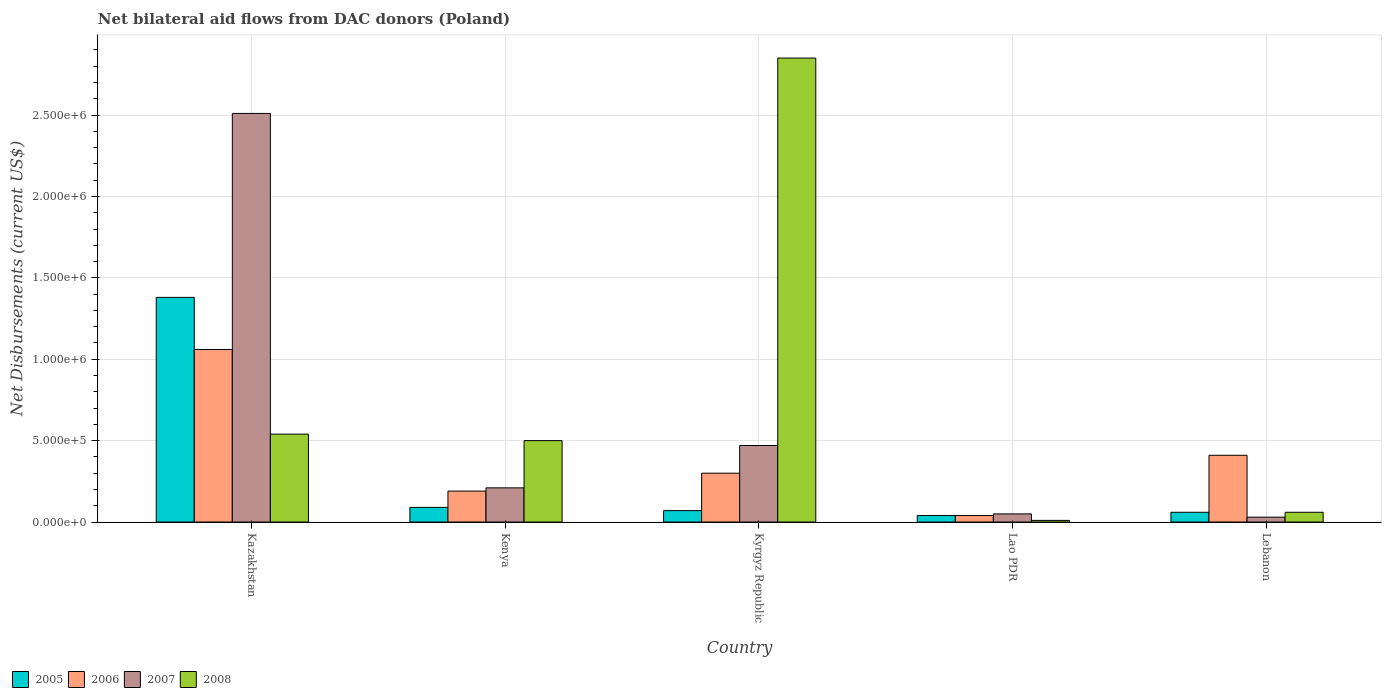How many different coloured bars are there?
Give a very brief answer. 4. How many groups of bars are there?
Ensure brevity in your answer.  5. Are the number of bars per tick equal to the number of legend labels?
Provide a short and direct response. Yes. Are the number of bars on each tick of the X-axis equal?
Keep it short and to the point. Yes. How many bars are there on the 1st tick from the left?
Offer a very short reply. 4. How many bars are there on the 4th tick from the right?
Your answer should be compact. 4. What is the label of the 5th group of bars from the left?
Give a very brief answer. Lebanon. In how many cases, is the number of bars for a given country not equal to the number of legend labels?
Your answer should be very brief. 0. What is the net bilateral aid flows in 2006 in Lebanon?
Keep it short and to the point. 4.10e+05. Across all countries, what is the maximum net bilateral aid flows in 2005?
Offer a very short reply. 1.38e+06. In which country was the net bilateral aid flows in 2006 maximum?
Give a very brief answer. Kazakhstan. In which country was the net bilateral aid flows in 2007 minimum?
Ensure brevity in your answer.  Lebanon. What is the total net bilateral aid flows in 2005 in the graph?
Ensure brevity in your answer.  1.64e+06. What is the difference between the net bilateral aid flows in 2008 in Kazakhstan and that in Lao PDR?
Offer a terse response. 5.30e+05. What is the difference between the net bilateral aid flows in 2008 in Kenya and the net bilateral aid flows in 2005 in Lao PDR?
Keep it short and to the point. 4.60e+05. What is the average net bilateral aid flows in 2005 per country?
Offer a terse response. 3.28e+05. Is the net bilateral aid flows in 2005 in Kazakhstan less than that in Lao PDR?
Keep it short and to the point. No. What is the difference between the highest and the second highest net bilateral aid flows in 2007?
Your answer should be very brief. 2.04e+06. What is the difference between the highest and the lowest net bilateral aid flows in 2007?
Ensure brevity in your answer.  2.48e+06. What does the 3rd bar from the left in Kenya represents?
Offer a very short reply. 2007. How many bars are there?
Ensure brevity in your answer.  20. What is the difference between two consecutive major ticks on the Y-axis?
Give a very brief answer. 5.00e+05. Does the graph contain grids?
Your answer should be very brief. Yes. Where does the legend appear in the graph?
Make the answer very short. Bottom left. What is the title of the graph?
Provide a short and direct response. Net bilateral aid flows from DAC donors (Poland). Does "1991" appear as one of the legend labels in the graph?
Give a very brief answer. No. What is the label or title of the Y-axis?
Your answer should be compact. Net Disbursements (current US$). What is the Net Disbursements (current US$) in 2005 in Kazakhstan?
Your answer should be compact. 1.38e+06. What is the Net Disbursements (current US$) in 2006 in Kazakhstan?
Give a very brief answer. 1.06e+06. What is the Net Disbursements (current US$) of 2007 in Kazakhstan?
Provide a succinct answer. 2.51e+06. What is the Net Disbursements (current US$) of 2008 in Kazakhstan?
Your answer should be compact. 5.40e+05. What is the Net Disbursements (current US$) of 2005 in Kenya?
Make the answer very short. 9.00e+04. What is the Net Disbursements (current US$) in 2006 in Kenya?
Provide a succinct answer. 1.90e+05. What is the Net Disbursements (current US$) in 2007 in Kenya?
Your answer should be compact. 2.10e+05. What is the Net Disbursements (current US$) in 2006 in Kyrgyz Republic?
Provide a short and direct response. 3.00e+05. What is the Net Disbursements (current US$) of 2007 in Kyrgyz Republic?
Offer a very short reply. 4.70e+05. What is the Net Disbursements (current US$) of 2008 in Kyrgyz Republic?
Provide a succinct answer. 2.85e+06. What is the Net Disbursements (current US$) of 2005 in Lebanon?
Offer a very short reply. 6.00e+04. What is the Net Disbursements (current US$) in 2006 in Lebanon?
Ensure brevity in your answer.  4.10e+05. What is the Net Disbursements (current US$) of 2007 in Lebanon?
Keep it short and to the point. 3.00e+04. What is the Net Disbursements (current US$) in 2008 in Lebanon?
Offer a very short reply. 6.00e+04. Across all countries, what is the maximum Net Disbursements (current US$) in 2005?
Your answer should be compact. 1.38e+06. Across all countries, what is the maximum Net Disbursements (current US$) in 2006?
Your answer should be compact. 1.06e+06. Across all countries, what is the maximum Net Disbursements (current US$) in 2007?
Give a very brief answer. 2.51e+06. Across all countries, what is the maximum Net Disbursements (current US$) of 2008?
Your answer should be compact. 2.85e+06. Across all countries, what is the minimum Net Disbursements (current US$) of 2007?
Provide a succinct answer. 3.00e+04. What is the total Net Disbursements (current US$) in 2005 in the graph?
Ensure brevity in your answer.  1.64e+06. What is the total Net Disbursements (current US$) of 2006 in the graph?
Keep it short and to the point. 2.00e+06. What is the total Net Disbursements (current US$) of 2007 in the graph?
Ensure brevity in your answer.  3.27e+06. What is the total Net Disbursements (current US$) of 2008 in the graph?
Offer a terse response. 3.96e+06. What is the difference between the Net Disbursements (current US$) of 2005 in Kazakhstan and that in Kenya?
Your answer should be compact. 1.29e+06. What is the difference between the Net Disbursements (current US$) in 2006 in Kazakhstan and that in Kenya?
Offer a very short reply. 8.70e+05. What is the difference between the Net Disbursements (current US$) in 2007 in Kazakhstan and that in Kenya?
Provide a short and direct response. 2.30e+06. What is the difference between the Net Disbursements (current US$) of 2005 in Kazakhstan and that in Kyrgyz Republic?
Your response must be concise. 1.31e+06. What is the difference between the Net Disbursements (current US$) of 2006 in Kazakhstan and that in Kyrgyz Republic?
Your answer should be very brief. 7.60e+05. What is the difference between the Net Disbursements (current US$) of 2007 in Kazakhstan and that in Kyrgyz Republic?
Make the answer very short. 2.04e+06. What is the difference between the Net Disbursements (current US$) of 2008 in Kazakhstan and that in Kyrgyz Republic?
Your answer should be very brief. -2.31e+06. What is the difference between the Net Disbursements (current US$) in 2005 in Kazakhstan and that in Lao PDR?
Offer a terse response. 1.34e+06. What is the difference between the Net Disbursements (current US$) of 2006 in Kazakhstan and that in Lao PDR?
Your response must be concise. 1.02e+06. What is the difference between the Net Disbursements (current US$) in 2007 in Kazakhstan and that in Lao PDR?
Provide a short and direct response. 2.46e+06. What is the difference between the Net Disbursements (current US$) of 2008 in Kazakhstan and that in Lao PDR?
Your answer should be very brief. 5.30e+05. What is the difference between the Net Disbursements (current US$) in 2005 in Kazakhstan and that in Lebanon?
Give a very brief answer. 1.32e+06. What is the difference between the Net Disbursements (current US$) in 2006 in Kazakhstan and that in Lebanon?
Your response must be concise. 6.50e+05. What is the difference between the Net Disbursements (current US$) of 2007 in Kazakhstan and that in Lebanon?
Your answer should be compact. 2.48e+06. What is the difference between the Net Disbursements (current US$) in 2005 in Kenya and that in Kyrgyz Republic?
Keep it short and to the point. 2.00e+04. What is the difference between the Net Disbursements (current US$) of 2006 in Kenya and that in Kyrgyz Republic?
Offer a very short reply. -1.10e+05. What is the difference between the Net Disbursements (current US$) in 2008 in Kenya and that in Kyrgyz Republic?
Provide a short and direct response. -2.35e+06. What is the difference between the Net Disbursements (current US$) in 2005 in Kenya and that in Lao PDR?
Your answer should be compact. 5.00e+04. What is the difference between the Net Disbursements (current US$) in 2008 in Kenya and that in Lao PDR?
Make the answer very short. 4.90e+05. What is the difference between the Net Disbursements (current US$) of 2005 in Kenya and that in Lebanon?
Provide a succinct answer. 3.00e+04. What is the difference between the Net Disbursements (current US$) of 2006 in Kenya and that in Lebanon?
Offer a very short reply. -2.20e+05. What is the difference between the Net Disbursements (current US$) in 2007 in Kyrgyz Republic and that in Lao PDR?
Offer a very short reply. 4.20e+05. What is the difference between the Net Disbursements (current US$) of 2008 in Kyrgyz Republic and that in Lao PDR?
Offer a terse response. 2.84e+06. What is the difference between the Net Disbursements (current US$) in 2005 in Kyrgyz Republic and that in Lebanon?
Keep it short and to the point. 10000. What is the difference between the Net Disbursements (current US$) in 2006 in Kyrgyz Republic and that in Lebanon?
Give a very brief answer. -1.10e+05. What is the difference between the Net Disbursements (current US$) of 2008 in Kyrgyz Republic and that in Lebanon?
Your answer should be very brief. 2.79e+06. What is the difference between the Net Disbursements (current US$) of 2005 in Lao PDR and that in Lebanon?
Keep it short and to the point. -2.00e+04. What is the difference between the Net Disbursements (current US$) of 2006 in Lao PDR and that in Lebanon?
Your answer should be very brief. -3.70e+05. What is the difference between the Net Disbursements (current US$) of 2007 in Lao PDR and that in Lebanon?
Your answer should be very brief. 2.00e+04. What is the difference between the Net Disbursements (current US$) in 2005 in Kazakhstan and the Net Disbursements (current US$) in 2006 in Kenya?
Ensure brevity in your answer.  1.19e+06. What is the difference between the Net Disbursements (current US$) of 2005 in Kazakhstan and the Net Disbursements (current US$) of 2007 in Kenya?
Your answer should be compact. 1.17e+06. What is the difference between the Net Disbursements (current US$) in 2005 in Kazakhstan and the Net Disbursements (current US$) in 2008 in Kenya?
Ensure brevity in your answer.  8.80e+05. What is the difference between the Net Disbursements (current US$) of 2006 in Kazakhstan and the Net Disbursements (current US$) of 2007 in Kenya?
Ensure brevity in your answer.  8.50e+05. What is the difference between the Net Disbursements (current US$) in 2006 in Kazakhstan and the Net Disbursements (current US$) in 2008 in Kenya?
Provide a succinct answer. 5.60e+05. What is the difference between the Net Disbursements (current US$) in 2007 in Kazakhstan and the Net Disbursements (current US$) in 2008 in Kenya?
Ensure brevity in your answer.  2.01e+06. What is the difference between the Net Disbursements (current US$) of 2005 in Kazakhstan and the Net Disbursements (current US$) of 2006 in Kyrgyz Republic?
Ensure brevity in your answer.  1.08e+06. What is the difference between the Net Disbursements (current US$) in 2005 in Kazakhstan and the Net Disbursements (current US$) in 2007 in Kyrgyz Republic?
Provide a succinct answer. 9.10e+05. What is the difference between the Net Disbursements (current US$) in 2005 in Kazakhstan and the Net Disbursements (current US$) in 2008 in Kyrgyz Republic?
Your response must be concise. -1.47e+06. What is the difference between the Net Disbursements (current US$) of 2006 in Kazakhstan and the Net Disbursements (current US$) of 2007 in Kyrgyz Republic?
Offer a terse response. 5.90e+05. What is the difference between the Net Disbursements (current US$) in 2006 in Kazakhstan and the Net Disbursements (current US$) in 2008 in Kyrgyz Republic?
Make the answer very short. -1.79e+06. What is the difference between the Net Disbursements (current US$) in 2005 in Kazakhstan and the Net Disbursements (current US$) in 2006 in Lao PDR?
Offer a terse response. 1.34e+06. What is the difference between the Net Disbursements (current US$) in 2005 in Kazakhstan and the Net Disbursements (current US$) in 2007 in Lao PDR?
Your response must be concise. 1.33e+06. What is the difference between the Net Disbursements (current US$) in 2005 in Kazakhstan and the Net Disbursements (current US$) in 2008 in Lao PDR?
Give a very brief answer. 1.37e+06. What is the difference between the Net Disbursements (current US$) in 2006 in Kazakhstan and the Net Disbursements (current US$) in 2007 in Lao PDR?
Ensure brevity in your answer.  1.01e+06. What is the difference between the Net Disbursements (current US$) of 2006 in Kazakhstan and the Net Disbursements (current US$) of 2008 in Lao PDR?
Provide a succinct answer. 1.05e+06. What is the difference between the Net Disbursements (current US$) of 2007 in Kazakhstan and the Net Disbursements (current US$) of 2008 in Lao PDR?
Ensure brevity in your answer.  2.50e+06. What is the difference between the Net Disbursements (current US$) of 2005 in Kazakhstan and the Net Disbursements (current US$) of 2006 in Lebanon?
Provide a succinct answer. 9.70e+05. What is the difference between the Net Disbursements (current US$) in 2005 in Kazakhstan and the Net Disbursements (current US$) in 2007 in Lebanon?
Offer a terse response. 1.35e+06. What is the difference between the Net Disbursements (current US$) in 2005 in Kazakhstan and the Net Disbursements (current US$) in 2008 in Lebanon?
Your response must be concise. 1.32e+06. What is the difference between the Net Disbursements (current US$) in 2006 in Kazakhstan and the Net Disbursements (current US$) in 2007 in Lebanon?
Your answer should be very brief. 1.03e+06. What is the difference between the Net Disbursements (current US$) of 2007 in Kazakhstan and the Net Disbursements (current US$) of 2008 in Lebanon?
Offer a very short reply. 2.45e+06. What is the difference between the Net Disbursements (current US$) in 2005 in Kenya and the Net Disbursements (current US$) in 2006 in Kyrgyz Republic?
Ensure brevity in your answer.  -2.10e+05. What is the difference between the Net Disbursements (current US$) in 2005 in Kenya and the Net Disbursements (current US$) in 2007 in Kyrgyz Republic?
Offer a terse response. -3.80e+05. What is the difference between the Net Disbursements (current US$) of 2005 in Kenya and the Net Disbursements (current US$) of 2008 in Kyrgyz Republic?
Offer a terse response. -2.76e+06. What is the difference between the Net Disbursements (current US$) of 2006 in Kenya and the Net Disbursements (current US$) of 2007 in Kyrgyz Republic?
Ensure brevity in your answer.  -2.80e+05. What is the difference between the Net Disbursements (current US$) of 2006 in Kenya and the Net Disbursements (current US$) of 2008 in Kyrgyz Republic?
Provide a succinct answer. -2.66e+06. What is the difference between the Net Disbursements (current US$) of 2007 in Kenya and the Net Disbursements (current US$) of 2008 in Kyrgyz Republic?
Offer a very short reply. -2.64e+06. What is the difference between the Net Disbursements (current US$) of 2005 in Kenya and the Net Disbursements (current US$) of 2007 in Lao PDR?
Your answer should be very brief. 4.00e+04. What is the difference between the Net Disbursements (current US$) in 2005 in Kenya and the Net Disbursements (current US$) in 2008 in Lao PDR?
Offer a terse response. 8.00e+04. What is the difference between the Net Disbursements (current US$) in 2006 in Kenya and the Net Disbursements (current US$) in 2007 in Lao PDR?
Offer a very short reply. 1.40e+05. What is the difference between the Net Disbursements (current US$) in 2006 in Kenya and the Net Disbursements (current US$) in 2008 in Lao PDR?
Give a very brief answer. 1.80e+05. What is the difference between the Net Disbursements (current US$) in 2005 in Kenya and the Net Disbursements (current US$) in 2006 in Lebanon?
Offer a terse response. -3.20e+05. What is the difference between the Net Disbursements (current US$) in 2006 in Kenya and the Net Disbursements (current US$) in 2007 in Lebanon?
Your response must be concise. 1.60e+05. What is the difference between the Net Disbursements (current US$) in 2006 in Kenya and the Net Disbursements (current US$) in 2008 in Lebanon?
Your answer should be compact. 1.30e+05. What is the difference between the Net Disbursements (current US$) of 2006 in Kyrgyz Republic and the Net Disbursements (current US$) of 2008 in Lao PDR?
Keep it short and to the point. 2.90e+05. What is the difference between the Net Disbursements (current US$) of 2005 in Kyrgyz Republic and the Net Disbursements (current US$) of 2006 in Lebanon?
Your answer should be compact. -3.40e+05. What is the difference between the Net Disbursements (current US$) of 2005 in Kyrgyz Republic and the Net Disbursements (current US$) of 2007 in Lebanon?
Provide a short and direct response. 4.00e+04. What is the difference between the Net Disbursements (current US$) in 2005 in Kyrgyz Republic and the Net Disbursements (current US$) in 2008 in Lebanon?
Ensure brevity in your answer.  10000. What is the difference between the Net Disbursements (current US$) in 2006 in Kyrgyz Republic and the Net Disbursements (current US$) in 2008 in Lebanon?
Provide a succinct answer. 2.40e+05. What is the difference between the Net Disbursements (current US$) of 2007 in Kyrgyz Republic and the Net Disbursements (current US$) of 2008 in Lebanon?
Your answer should be compact. 4.10e+05. What is the difference between the Net Disbursements (current US$) in 2005 in Lao PDR and the Net Disbursements (current US$) in 2006 in Lebanon?
Provide a succinct answer. -3.70e+05. What is the difference between the Net Disbursements (current US$) in 2005 in Lao PDR and the Net Disbursements (current US$) in 2008 in Lebanon?
Keep it short and to the point. -2.00e+04. What is the difference between the Net Disbursements (current US$) in 2006 in Lao PDR and the Net Disbursements (current US$) in 2007 in Lebanon?
Make the answer very short. 10000. What is the difference between the Net Disbursements (current US$) in 2006 in Lao PDR and the Net Disbursements (current US$) in 2008 in Lebanon?
Provide a succinct answer. -2.00e+04. What is the average Net Disbursements (current US$) of 2005 per country?
Offer a very short reply. 3.28e+05. What is the average Net Disbursements (current US$) in 2006 per country?
Give a very brief answer. 4.00e+05. What is the average Net Disbursements (current US$) in 2007 per country?
Ensure brevity in your answer.  6.54e+05. What is the average Net Disbursements (current US$) in 2008 per country?
Keep it short and to the point. 7.92e+05. What is the difference between the Net Disbursements (current US$) in 2005 and Net Disbursements (current US$) in 2007 in Kazakhstan?
Your answer should be compact. -1.13e+06. What is the difference between the Net Disbursements (current US$) in 2005 and Net Disbursements (current US$) in 2008 in Kazakhstan?
Keep it short and to the point. 8.40e+05. What is the difference between the Net Disbursements (current US$) of 2006 and Net Disbursements (current US$) of 2007 in Kazakhstan?
Your answer should be compact. -1.45e+06. What is the difference between the Net Disbursements (current US$) of 2006 and Net Disbursements (current US$) of 2008 in Kazakhstan?
Your response must be concise. 5.20e+05. What is the difference between the Net Disbursements (current US$) of 2007 and Net Disbursements (current US$) of 2008 in Kazakhstan?
Make the answer very short. 1.97e+06. What is the difference between the Net Disbursements (current US$) in 2005 and Net Disbursements (current US$) in 2006 in Kenya?
Provide a succinct answer. -1.00e+05. What is the difference between the Net Disbursements (current US$) of 2005 and Net Disbursements (current US$) of 2008 in Kenya?
Give a very brief answer. -4.10e+05. What is the difference between the Net Disbursements (current US$) in 2006 and Net Disbursements (current US$) in 2007 in Kenya?
Give a very brief answer. -2.00e+04. What is the difference between the Net Disbursements (current US$) in 2006 and Net Disbursements (current US$) in 2008 in Kenya?
Provide a succinct answer. -3.10e+05. What is the difference between the Net Disbursements (current US$) of 2007 and Net Disbursements (current US$) of 2008 in Kenya?
Ensure brevity in your answer.  -2.90e+05. What is the difference between the Net Disbursements (current US$) of 2005 and Net Disbursements (current US$) of 2006 in Kyrgyz Republic?
Make the answer very short. -2.30e+05. What is the difference between the Net Disbursements (current US$) in 2005 and Net Disbursements (current US$) in 2007 in Kyrgyz Republic?
Provide a succinct answer. -4.00e+05. What is the difference between the Net Disbursements (current US$) in 2005 and Net Disbursements (current US$) in 2008 in Kyrgyz Republic?
Your answer should be very brief. -2.78e+06. What is the difference between the Net Disbursements (current US$) of 2006 and Net Disbursements (current US$) of 2008 in Kyrgyz Republic?
Offer a terse response. -2.55e+06. What is the difference between the Net Disbursements (current US$) of 2007 and Net Disbursements (current US$) of 2008 in Kyrgyz Republic?
Your answer should be very brief. -2.38e+06. What is the difference between the Net Disbursements (current US$) in 2005 and Net Disbursements (current US$) in 2006 in Lao PDR?
Keep it short and to the point. 0. What is the difference between the Net Disbursements (current US$) of 2005 and Net Disbursements (current US$) of 2007 in Lao PDR?
Provide a short and direct response. -10000. What is the difference between the Net Disbursements (current US$) of 2006 and Net Disbursements (current US$) of 2008 in Lao PDR?
Your answer should be compact. 3.00e+04. What is the difference between the Net Disbursements (current US$) of 2007 and Net Disbursements (current US$) of 2008 in Lao PDR?
Offer a terse response. 4.00e+04. What is the difference between the Net Disbursements (current US$) in 2005 and Net Disbursements (current US$) in 2006 in Lebanon?
Keep it short and to the point. -3.50e+05. What is the difference between the Net Disbursements (current US$) of 2005 and Net Disbursements (current US$) of 2007 in Lebanon?
Keep it short and to the point. 3.00e+04. What is the difference between the Net Disbursements (current US$) of 2005 and Net Disbursements (current US$) of 2008 in Lebanon?
Ensure brevity in your answer.  0. What is the difference between the Net Disbursements (current US$) of 2006 and Net Disbursements (current US$) of 2007 in Lebanon?
Give a very brief answer. 3.80e+05. What is the difference between the Net Disbursements (current US$) of 2007 and Net Disbursements (current US$) of 2008 in Lebanon?
Provide a short and direct response. -3.00e+04. What is the ratio of the Net Disbursements (current US$) of 2005 in Kazakhstan to that in Kenya?
Your answer should be very brief. 15.33. What is the ratio of the Net Disbursements (current US$) in 2006 in Kazakhstan to that in Kenya?
Make the answer very short. 5.58. What is the ratio of the Net Disbursements (current US$) in 2007 in Kazakhstan to that in Kenya?
Keep it short and to the point. 11.95. What is the ratio of the Net Disbursements (current US$) of 2008 in Kazakhstan to that in Kenya?
Offer a very short reply. 1.08. What is the ratio of the Net Disbursements (current US$) in 2005 in Kazakhstan to that in Kyrgyz Republic?
Your answer should be very brief. 19.71. What is the ratio of the Net Disbursements (current US$) in 2006 in Kazakhstan to that in Kyrgyz Republic?
Ensure brevity in your answer.  3.53. What is the ratio of the Net Disbursements (current US$) of 2007 in Kazakhstan to that in Kyrgyz Republic?
Provide a short and direct response. 5.34. What is the ratio of the Net Disbursements (current US$) in 2008 in Kazakhstan to that in Kyrgyz Republic?
Your answer should be very brief. 0.19. What is the ratio of the Net Disbursements (current US$) in 2005 in Kazakhstan to that in Lao PDR?
Your answer should be compact. 34.5. What is the ratio of the Net Disbursements (current US$) of 2006 in Kazakhstan to that in Lao PDR?
Your answer should be very brief. 26.5. What is the ratio of the Net Disbursements (current US$) in 2007 in Kazakhstan to that in Lao PDR?
Keep it short and to the point. 50.2. What is the ratio of the Net Disbursements (current US$) of 2008 in Kazakhstan to that in Lao PDR?
Your answer should be very brief. 54. What is the ratio of the Net Disbursements (current US$) in 2006 in Kazakhstan to that in Lebanon?
Ensure brevity in your answer.  2.59. What is the ratio of the Net Disbursements (current US$) of 2007 in Kazakhstan to that in Lebanon?
Provide a succinct answer. 83.67. What is the ratio of the Net Disbursements (current US$) in 2008 in Kazakhstan to that in Lebanon?
Your response must be concise. 9. What is the ratio of the Net Disbursements (current US$) in 2005 in Kenya to that in Kyrgyz Republic?
Make the answer very short. 1.29. What is the ratio of the Net Disbursements (current US$) of 2006 in Kenya to that in Kyrgyz Republic?
Ensure brevity in your answer.  0.63. What is the ratio of the Net Disbursements (current US$) in 2007 in Kenya to that in Kyrgyz Republic?
Your answer should be compact. 0.45. What is the ratio of the Net Disbursements (current US$) of 2008 in Kenya to that in Kyrgyz Republic?
Provide a short and direct response. 0.18. What is the ratio of the Net Disbursements (current US$) in 2005 in Kenya to that in Lao PDR?
Make the answer very short. 2.25. What is the ratio of the Net Disbursements (current US$) in 2006 in Kenya to that in Lao PDR?
Keep it short and to the point. 4.75. What is the ratio of the Net Disbursements (current US$) of 2008 in Kenya to that in Lao PDR?
Your answer should be compact. 50. What is the ratio of the Net Disbursements (current US$) of 2005 in Kenya to that in Lebanon?
Keep it short and to the point. 1.5. What is the ratio of the Net Disbursements (current US$) of 2006 in Kenya to that in Lebanon?
Your answer should be compact. 0.46. What is the ratio of the Net Disbursements (current US$) of 2008 in Kenya to that in Lebanon?
Provide a succinct answer. 8.33. What is the ratio of the Net Disbursements (current US$) in 2005 in Kyrgyz Republic to that in Lao PDR?
Make the answer very short. 1.75. What is the ratio of the Net Disbursements (current US$) of 2006 in Kyrgyz Republic to that in Lao PDR?
Ensure brevity in your answer.  7.5. What is the ratio of the Net Disbursements (current US$) of 2007 in Kyrgyz Republic to that in Lao PDR?
Provide a short and direct response. 9.4. What is the ratio of the Net Disbursements (current US$) in 2008 in Kyrgyz Republic to that in Lao PDR?
Your response must be concise. 285. What is the ratio of the Net Disbursements (current US$) of 2006 in Kyrgyz Republic to that in Lebanon?
Your response must be concise. 0.73. What is the ratio of the Net Disbursements (current US$) in 2007 in Kyrgyz Republic to that in Lebanon?
Make the answer very short. 15.67. What is the ratio of the Net Disbursements (current US$) of 2008 in Kyrgyz Republic to that in Lebanon?
Give a very brief answer. 47.5. What is the ratio of the Net Disbursements (current US$) in 2006 in Lao PDR to that in Lebanon?
Give a very brief answer. 0.1. What is the ratio of the Net Disbursements (current US$) in 2007 in Lao PDR to that in Lebanon?
Make the answer very short. 1.67. What is the ratio of the Net Disbursements (current US$) in 2008 in Lao PDR to that in Lebanon?
Make the answer very short. 0.17. What is the difference between the highest and the second highest Net Disbursements (current US$) in 2005?
Offer a terse response. 1.29e+06. What is the difference between the highest and the second highest Net Disbursements (current US$) of 2006?
Give a very brief answer. 6.50e+05. What is the difference between the highest and the second highest Net Disbursements (current US$) of 2007?
Offer a terse response. 2.04e+06. What is the difference between the highest and the second highest Net Disbursements (current US$) in 2008?
Provide a succinct answer. 2.31e+06. What is the difference between the highest and the lowest Net Disbursements (current US$) of 2005?
Your response must be concise. 1.34e+06. What is the difference between the highest and the lowest Net Disbursements (current US$) in 2006?
Provide a succinct answer. 1.02e+06. What is the difference between the highest and the lowest Net Disbursements (current US$) in 2007?
Ensure brevity in your answer.  2.48e+06. What is the difference between the highest and the lowest Net Disbursements (current US$) of 2008?
Provide a short and direct response. 2.84e+06. 